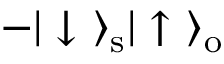<formula> <loc_0><loc_0><loc_500><loc_500>- | \downarrow \ \rangle _ { s } | \uparrow \ \rangle _ { o }</formula> 